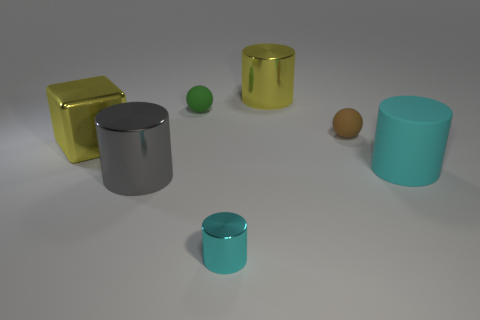What materials do these objects appear to be made of? The objects display a variety of sheens and colors that suggest they are made of different types of metals or materials with metallic finishes. The reflective surfaces and smooth textures are typically associated with metal or polished plastic. 